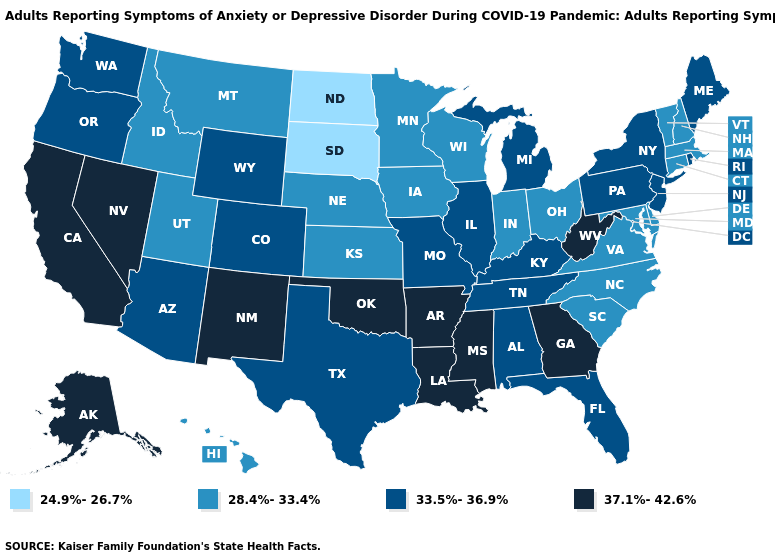What is the value of Kansas?
Short answer required. 28.4%-33.4%. Which states have the lowest value in the USA?
Short answer required. North Dakota, South Dakota. Which states have the lowest value in the Northeast?
Short answer required. Connecticut, Massachusetts, New Hampshire, Vermont. Among the states that border Idaho , does Montana have the lowest value?
Write a very short answer. Yes. Which states hav the highest value in the South?
Quick response, please. Arkansas, Georgia, Louisiana, Mississippi, Oklahoma, West Virginia. Name the states that have a value in the range 37.1%-42.6%?
Answer briefly. Alaska, Arkansas, California, Georgia, Louisiana, Mississippi, Nevada, New Mexico, Oklahoma, West Virginia. Name the states that have a value in the range 37.1%-42.6%?
Keep it brief. Alaska, Arkansas, California, Georgia, Louisiana, Mississippi, Nevada, New Mexico, Oklahoma, West Virginia. Does the first symbol in the legend represent the smallest category?
Give a very brief answer. Yes. What is the highest value in the West ?
Answer briefly. 37.1%-42.6%. Does Maryland have a lower value than Vermont?
Answer briefly. No. Name the states that have a value in the range 28.4%-33.4%?
Write a very short answer. Connecticut, Delaware, Hawaii, Idaho, Indiana, Iowa, Kansas, Maryland, Massachusetts, Minnesota, Montana, Nebraska, New Hampshire, North Carolina, Ohio, South Carolina, Utah, Vermont, Virginia, Wisconsin. Does North Dakota have the lowest value in the USA?
Give a very brief answer. Yes. How many symbols are there in the legend?
Keep it brief. 4. What is the highest value in states that border Utah?
Quick response, please. 37.1%-42.6%. Among the states that border Florida , does Georgia have the lowest value?
Concise answer only. No. 